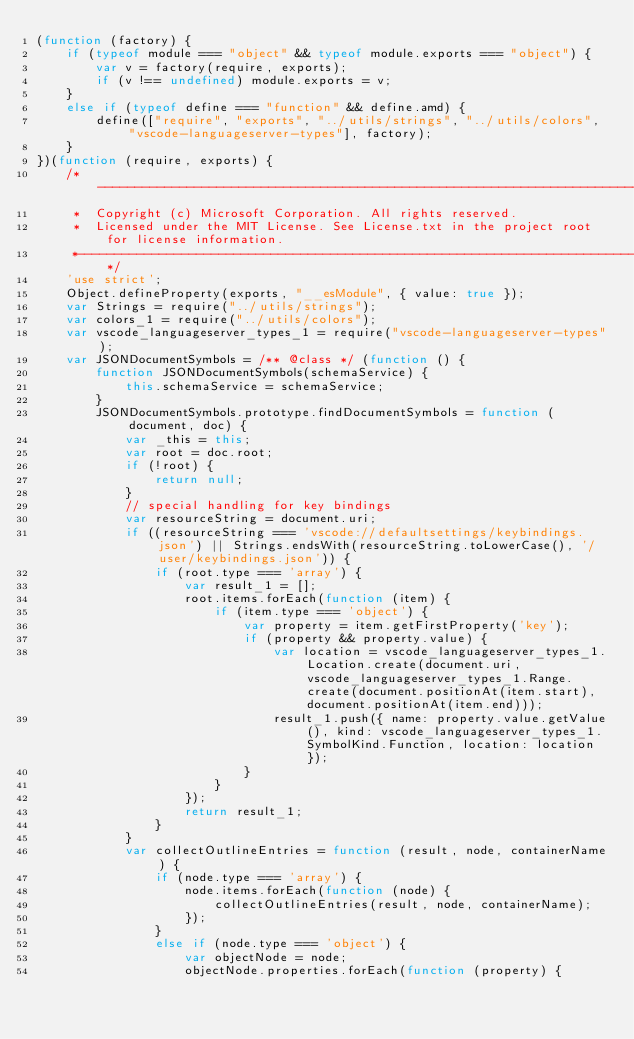<code> <loc_0><loc_0><loc_500><loc_500><_JavaScript_>(function (factory) {
    if (typeof module === "object" && typeof module.exports === "object") {
        var v = factory(require, exports);
        if (v !== undefined) module.exports = v;
    }
    else if (typeof define === "function" && define.amd) {
        define(["require", "exports", "../utils/strings", "../utils/colors", "vscode-languageserver-types"], factory);
    }
})(function (require, exports) {
    /*---------------------------------------------------------------------------------------------
     *  Copyright (c) Microsoft Corporation. All rights reserved.
     *  Licensed under the MIT License. See License.txt in the project root for license information.
     *--------------------------------------------------------------------------------------------*/
    'use strict';
    Object.defineProperty(exports, "__esModule", { value: true });
    var Strings = require("../utils/strings");
    var colors_1 = require("../utils/colors");
    var vscode_languageserver_types_1 = require("vscode-languageserver-types");
    var JSONDocumentSymbols = /** @class */ (function () {
        function JSONDocumentSymbols(schemaService) {
            this.schemaService = schemaService;
        }
        JSONDocumentSymbols.prototype.findDocumentSymbols = function (document, doc) {
            var _this = this;
            var root = doc.root;
            if (!root) {
                return null;
            }
            // special handling for key bindings
            var resourceString = document.uri;
            if ((resourceString === 'vscode://defaultsettings/keybindings.json') || Strings.endsWith(resourceString.toLowerCase(), '/user/keybindings.json')) {
                if (root.type === 'array') {
                    var result_1 = [];
                    root.items.forEach(function (item) {
                        if (item.type === 'object') {
                            var property = item.getFirstProperty('key');
                            if (property && property.value) {
                                var location = vscode_languageserver_types_1.Location.create(document.uri, vscode_languageserver_types_1.Range.create(document.positionAt(item.start), document.positionAt(item.end)));
                                result_1.push({ name: property.value.getValue(), kind: vscode_languageserver_types_1.SymbolKind.Function, location: location });
                            }
                        }
                    });
                    return result_1;
                }
            }
            var collectOutlineEntries = function (result, node, containerName) {
                if (node.type === 'array') {
                    node.items.forEach(function (node) {
                        collectOutlineEntries(result, node, containerName);
                    });
                }
                else if (node.type === 'object') {
                    var objectNode = node;
                    objectNode.properties.forEach(function (property) {</code> 